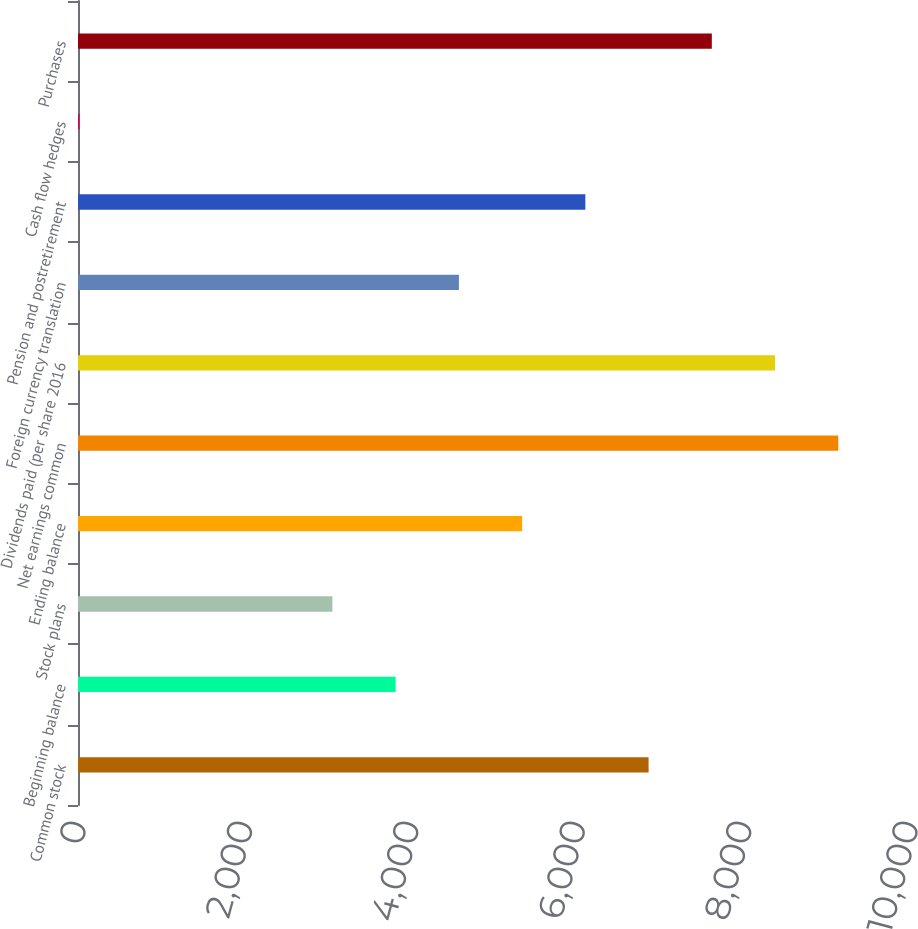Convert chart to OTSL. <chart><loc_0><loc_0><loc_500><loc_500><bar_chart><fcel>Common stock<fcel>Beginning balance<fcel>Stock plans<fcel>Ending balance<fcel>Net earnings common<fcel>Dividends paid (per share 2016<fcel>Foreign currency translation<fcel>Pension and postretirement<fcel>Cash flow hedges<fcel>Purchases<nl><fcel>6858<fcel>3818<fcel>3058<fcel>5338<fcel>9138<fcel>8378<fcel>4578<fcel>6098<fcel>18<fcel>7618<nl></chart> 